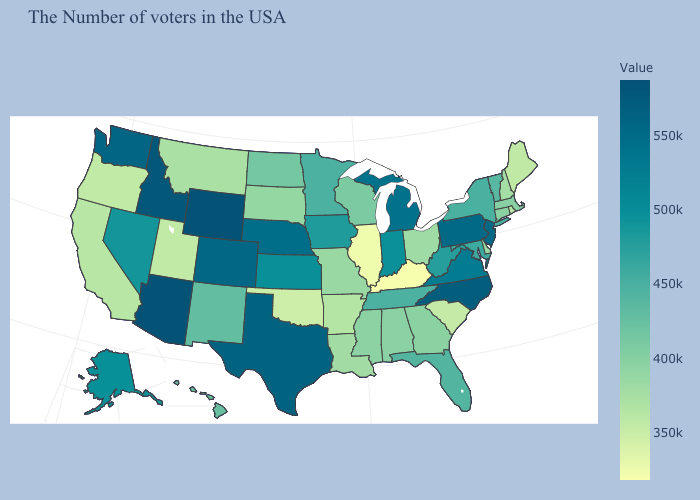Among the states that border Wisconsin , does Illinois have the lowest value?
Concise answer only. Yes. Which states have the lowest value in the South?
Write a very short answer. Kentucky. Does Utah have the highest value in the USA?
Keep it brief. No. Among the states that border Vermont , does New York have the highest value?
Write a very short answer. Yes. 